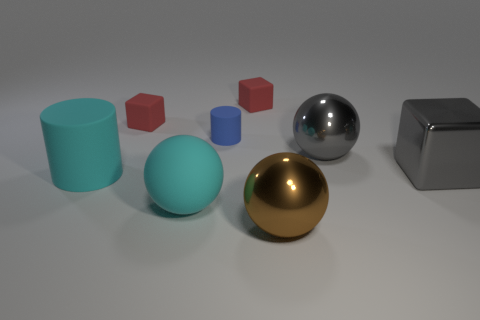Is the color of the large matte sphere the same as the big matte cylinder?
Ensure brevity in your answer.  Yes. What is the material of the thing that is the same color as the large block?
Give a very brief answer. Metal. Is there a thing that has the same color as the big matte cylinder?
Provide a succinct answer. Yes. The big cyan object behind the large sphere on the left side of the large brown sphere is made of what material?
Provide a short and direct response. Rubber. Are there the same number of small rubber cylinders in front of the gray ball and blue cylinders that are right of the large cyan ball?
Offer a very short reply. No. How many objects are either large metallic balls behind the gray block or blocks left of the gray metallic sphere?
Give a very brief answer. 3. What material is the object that is both on the right side of the cyan rubber ball and in front of the big cyan rubber cylinder?
Keep it short and to the point. Metal. What is the size of the cyan sphere that is in front of the big rubber cylinder that is in front of the gray thing on the left side of the gray shiny cube?
Provide a succinct answer. Large. Are there more cyan matte spheres than small cyan rubber things?
Provide a succinct answer. Yes. Is the material of the cylinder that is on the left side of the blue thing the same as the brown object?
Offer a very short reply. No. 